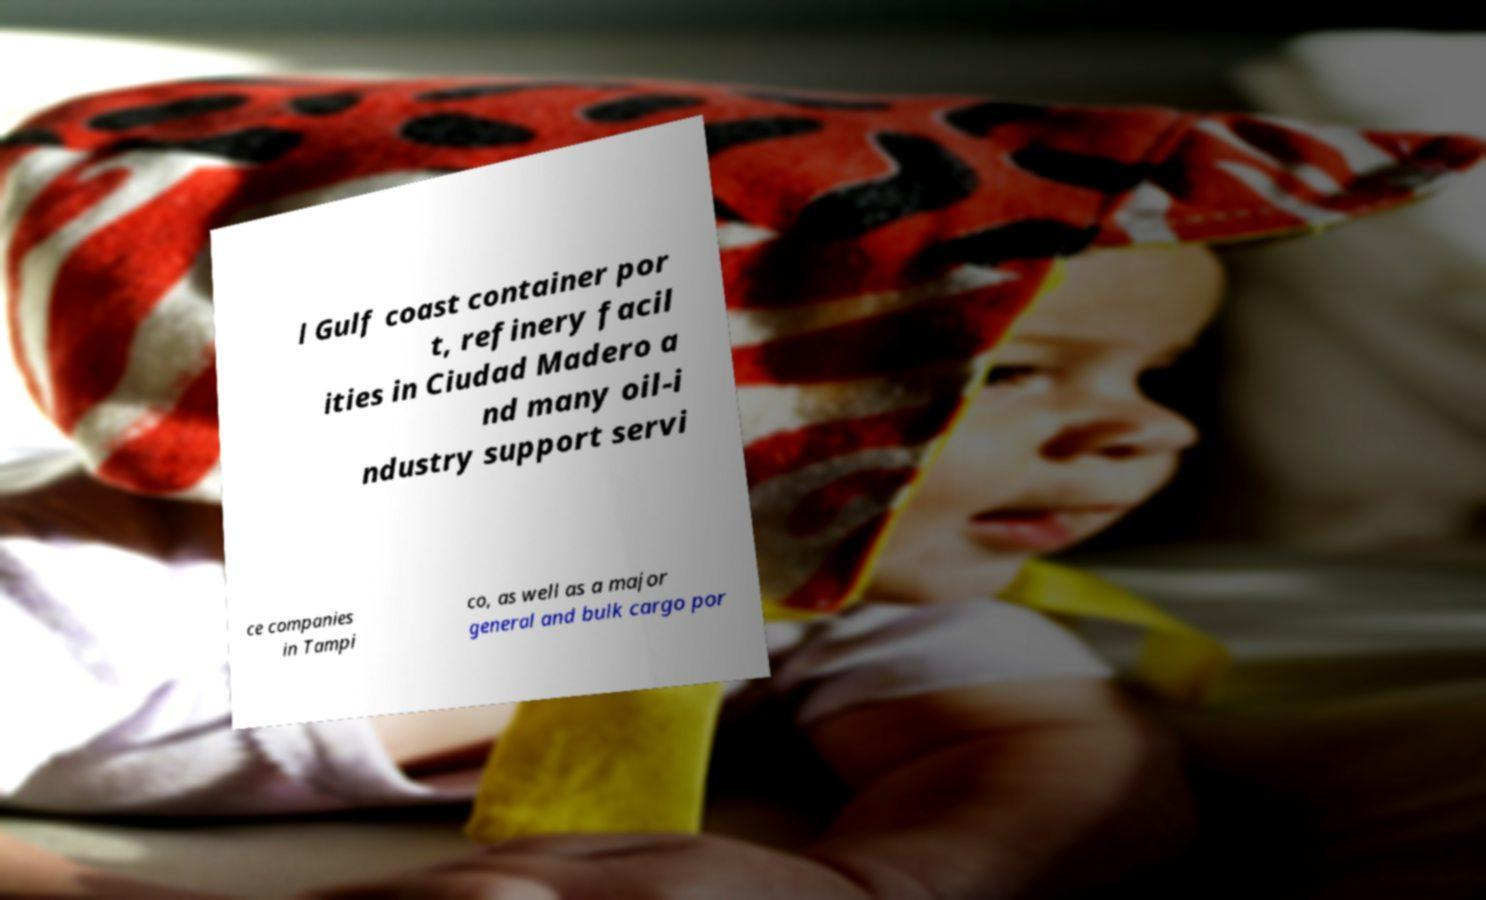For documentation purposes, I need the text within this image transcribed. Could you provide that? l Gulf coast container por t, refinery facil ities in Ciudad Madero a nd many oil-i ndustry support servi ce companies in Tampi co, as well as a major general and bulk cargo por 